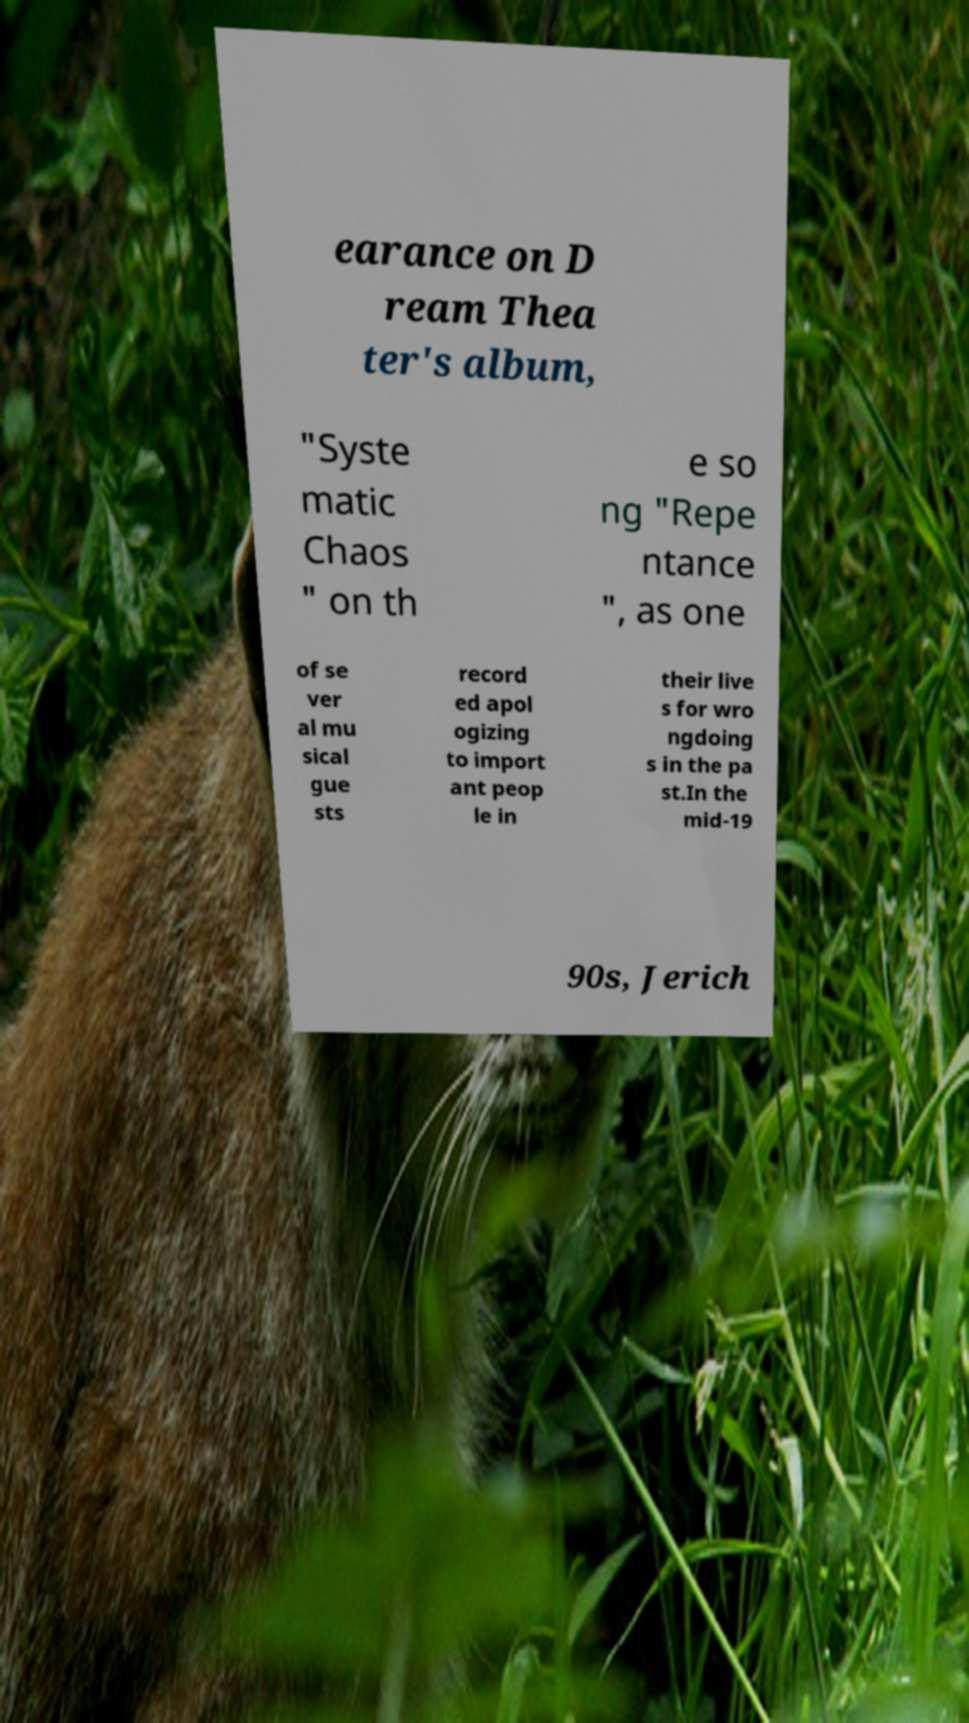Can you accurately transcribe the text from the provided image for me? earance on D ream Thea ter's album, "Syste matic Chaos " on th e so ng "Repe ntance ", as one of se ver al mu sical gue sts record ed apol ogizing to import ant peop le in their live s for wro ngdoing s in the pa st.In the mid-19 90s, Jerich 